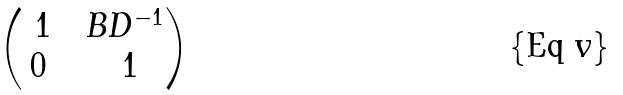<formula> <loc_0><loc_0><loc_500><loc_500>\begin{pmatrix} \ 1 & & B D ^ { - 1 } \\ 0 & & \ 1 \end{pmatrix}</formula> 